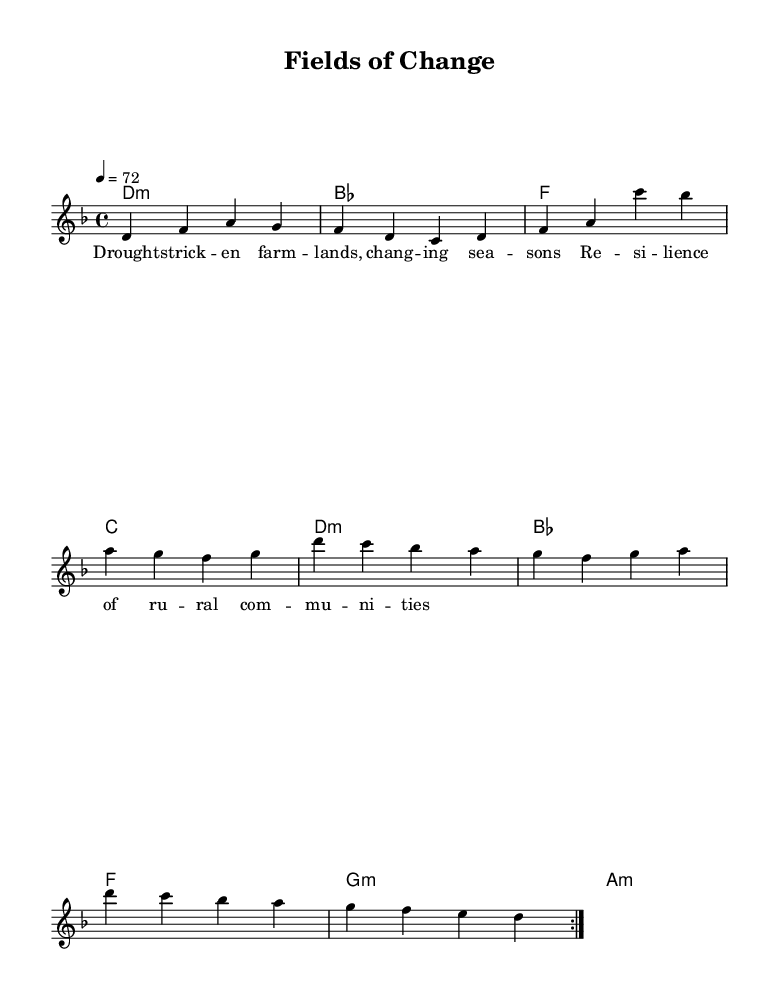What is the key signature of this music? The key signature is D minor, which has one flat (B flat).
Answer: D minor What is the time signature of this piece? The time signature is indicated at the beginning and is 4/4, meaning there are four beats in each measure.
Answer: 4/4 What is the tempo marking in this score? The tempo marking shows a number indicating beats per minute; here it's set at 72 beats per minute.
Answer: 72 How many times is the first section repeated? The score explicitly indicates repeat markings, showing that the first section is repeated twice.
Answer: 2 What type of harmonic progression is used in the chord changes? The chords follow a pattern characteristic of rock music, combining major and minor chords in a repetitive structure.
Answer: Major and minor What themes are expressed in the lyrical content? The lyrics focus on the themes of drought and resilience in rural communities, highlighting the impact of climate change on agriculture.
Answer: Drought, resilience What is the overall mood conveyed by the melody and lyrics? The combination of the minor key in the melody and somber theme in the lyrics suggests a reflective and serious mood throughout the piece.
Answer: Reflective 